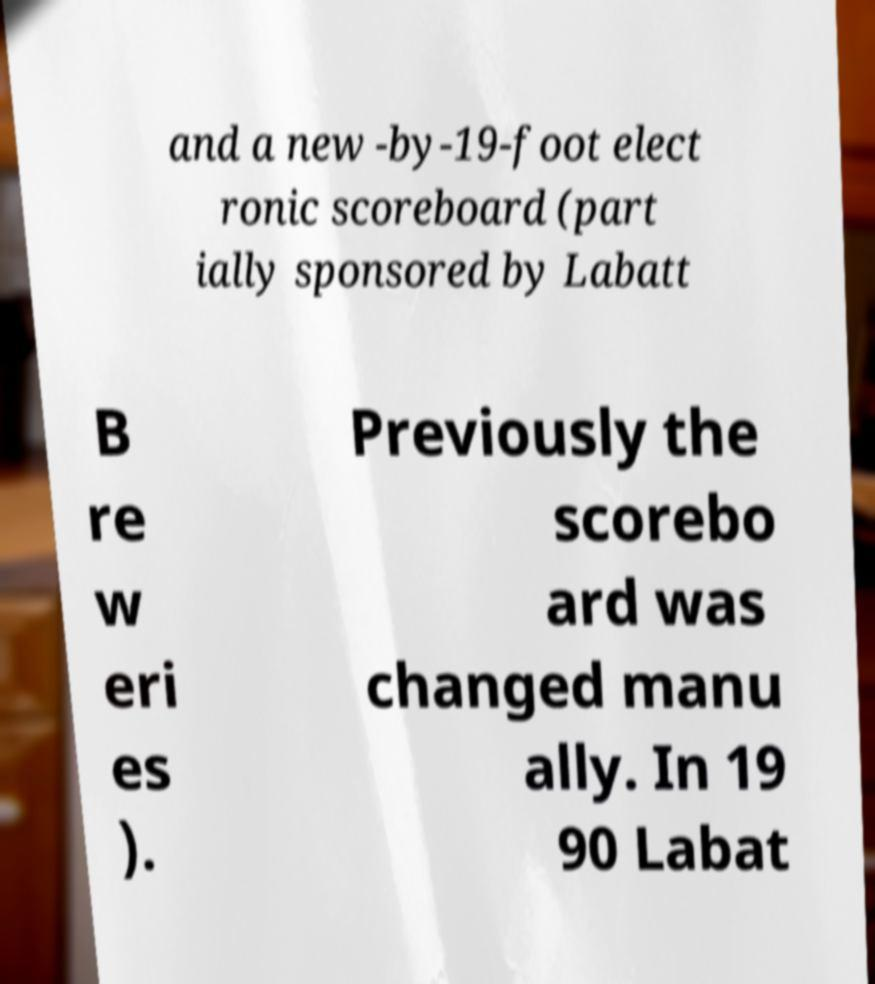What messages or text are displayed in this image? I need them in a readable, typed format. and a new -by-19-foot elect ronic scoreboard (part ially sponsored by Labatt B re w eri es ). Previously the scorebo ard was changed manu ally. In 19 90 Labat 